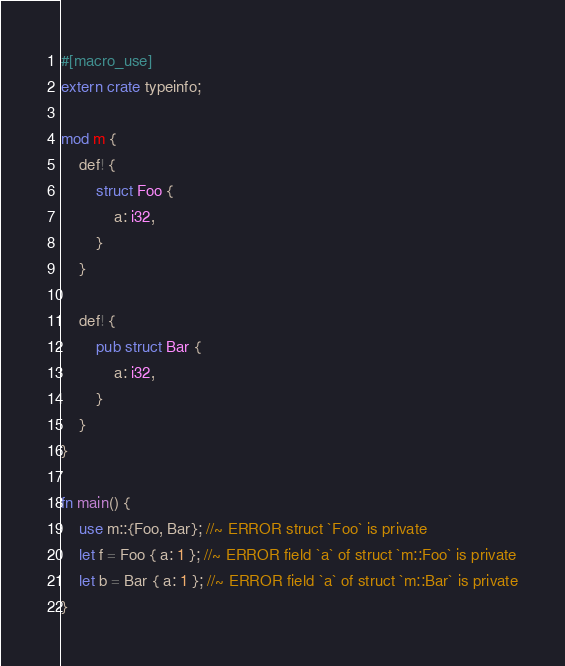Convert code to text. <code><loc_0><loc_0><loc_500><loc_500><_Rust_>#[macro_use]
extern crate typeinfo;

mod m {
    def! {
        struct Foo {
            a: i32,
        }
    }

    def! {
        pub struct Bar {
            a: i32,
        }
    }
}

fn main() {
    use m::{Foo, Bar}; //~ ERROR struct `Foo` is private
    let f = Foo { a: 1 }; //~ ERROR field `a` of struct `m::Foo` is private
    let b = Bar { a: 1 }; //~ ERROR field `a` of struct `m::Bar` is private
}
</code> 